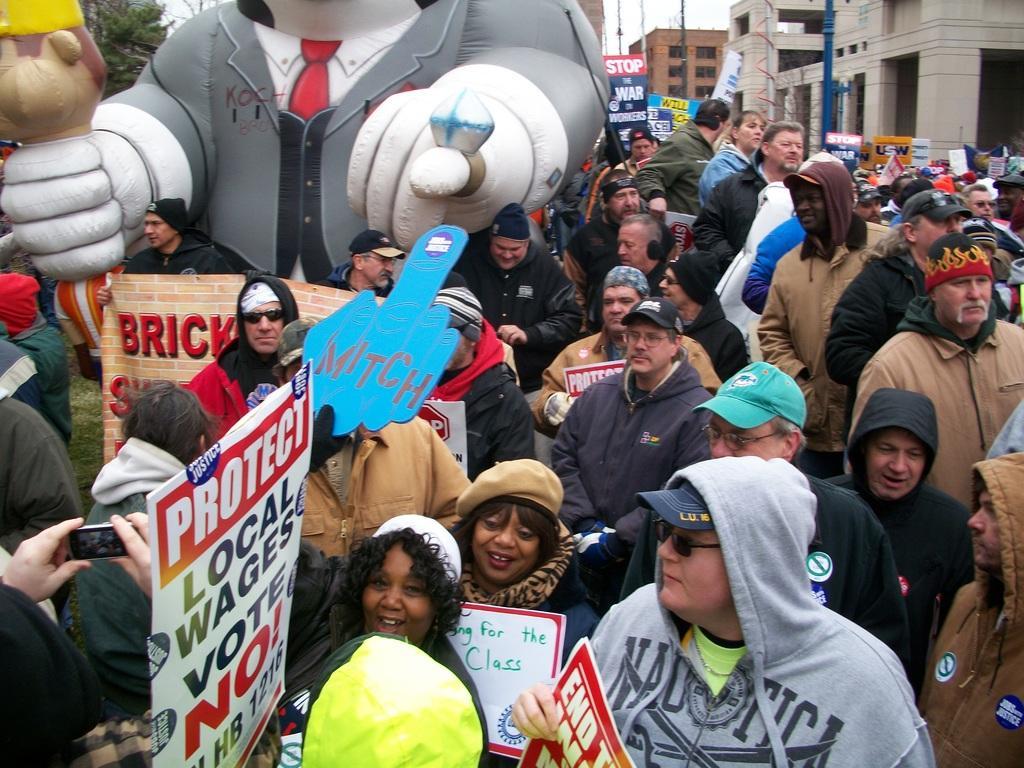How would you summarize this image in a sentence or two? In this picture we can see a group of people, posters, poles, camera, grass, trees, some objects and in the background we can see buildings and the sky. 